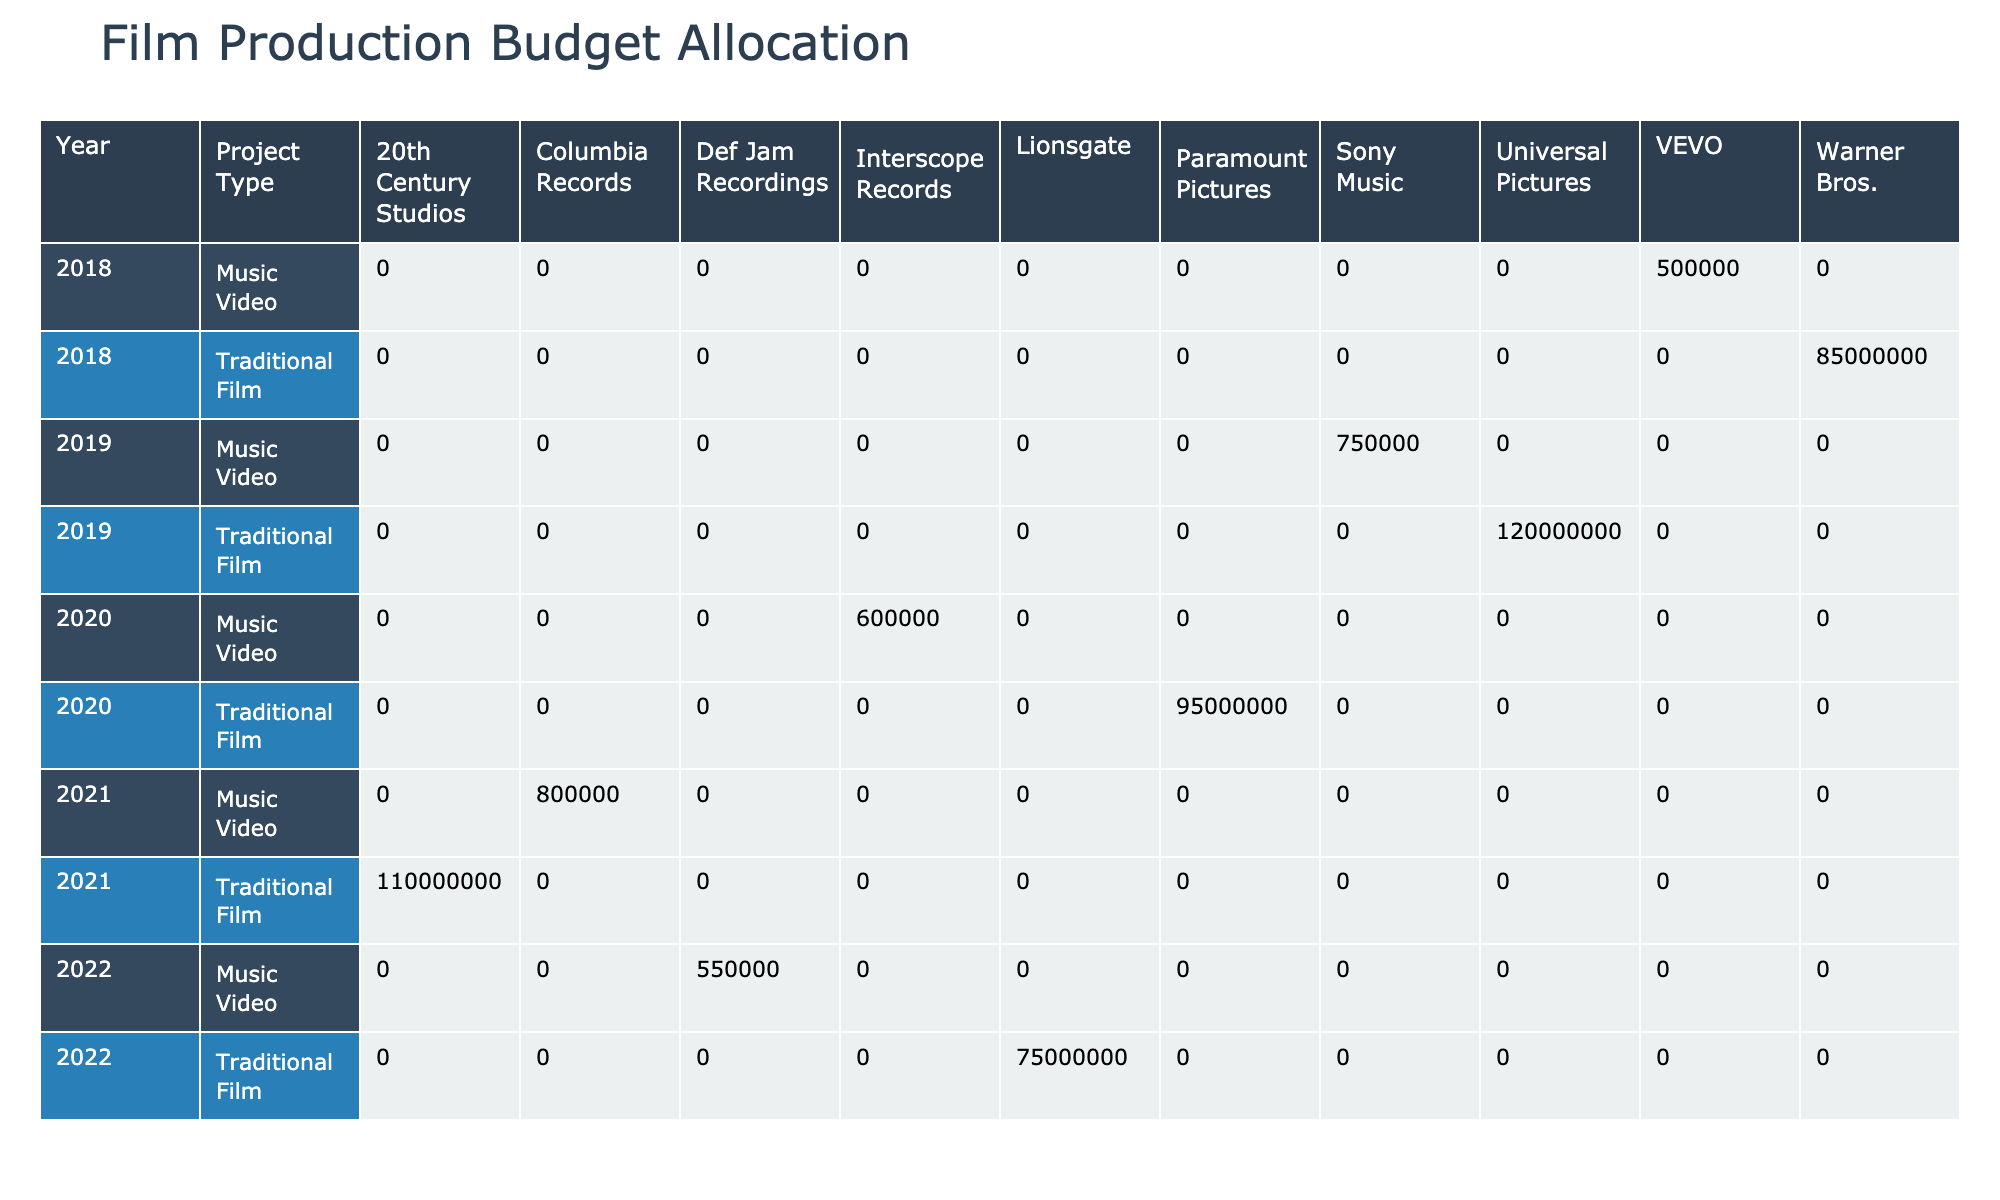What is the production budget for the Traditional Film by Warner Bros. in 2018? The table lists the budget for the Traditional Film by Warner Bros. as 85,000,000 USD in the row that corresponds to the year 2018 under the Project Type Traditional Film.
Answer: 85000000 What is the total budget for Music Video projects in 2021? The budget for Music Video projects in 2021 includes two entries: 800,000 USD for the Music Video by Columbia Records. Adding them up, 800,000 USD is the total as it is the only entry for that year.
Answer: 800000 Which production company had the highest budget for a Traditional Film in 2019? The table shows that in 2019, Universal Pictures had the highest budget for a Traditional Film at 120,000,000 USD.
Answer: Universal Pictures Is the budget for Music Video by Sony Music in 2019 greater than the budget for the Music Video by Interscope Records in 2020? The budget for Sony Music in 2019 is 750,000 USD, and for Interscope Records in 2020, it is 600,000 USD. Since 750,000 is greater than 600,000, the statement is true.
Answer: Yes What is the difference between the total budgets allocated to Set Design for Traditional Films and Music Videos in 2020? For Traditional Films in 2020, the budget for Set Design is 16,000,000 USD, and for Music Videos, it is 175,000 USD. Calculating the difference, 16,000,000 - 175,000 equals 15,825,000 USD.
Answer: 15825000 What is the average budget allocated for Marketing across all Music Video projects? The budgets for Marketing in Music Videos are 50,000, 75,000, 45,000, 50,000, and 40,000. Adding these gives 260,000, and dividing by the number of entries (5) yields an average of 52,000 USD.
Answer: 52000 What is the total budget allocated for Special Effects across all Traditional Films? The budgets for Special Effects in Traditional Films are 18,000,000 (2018) + 25,000,000 (2019) + 20,000,000 (2020) + 22,000,000 (2021) + 16,000,000 (2022), which sums up to 101,000,000 USD.
Answer: 101000000 Did Lionsgate have a Music Video project in 2022? The table does not list any Music Video project by Lionsgate for the year 2022, so the answer is no.
Answer: No Which Project Type had lower average budgets for the years represented in the table? The average budget for Traditional Films (adding all budgets and dividing by 5 projects) is 95,000,000 USD. The average budget for Music Videos (adding all budgets and dividing by 5 projects) is 590,000 USD. Since 590,000 is lower than 95,000,000, the lower average budget project type is Music Videos.
Answer: Music Video 